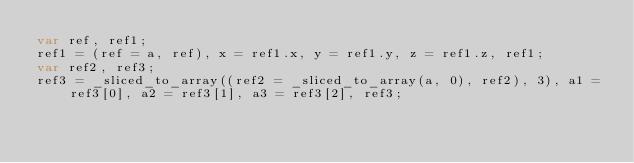<code> <loc_0><loc_0><loc_500><loc_500><_JavaScript_>var ref, ref1;
ref1 = (ref = a, ref), x = ref1.x, y = ref1.y, z = ref1.z, ref1;
var ref2, ref3;
ref3 = _sliced_to_array((ref2 = _sliced_to_array(a, 0), ref2), 3), a1 = ref3[0], a2 = ref3[1], a3 = ref3[2], ref3;
</code> 